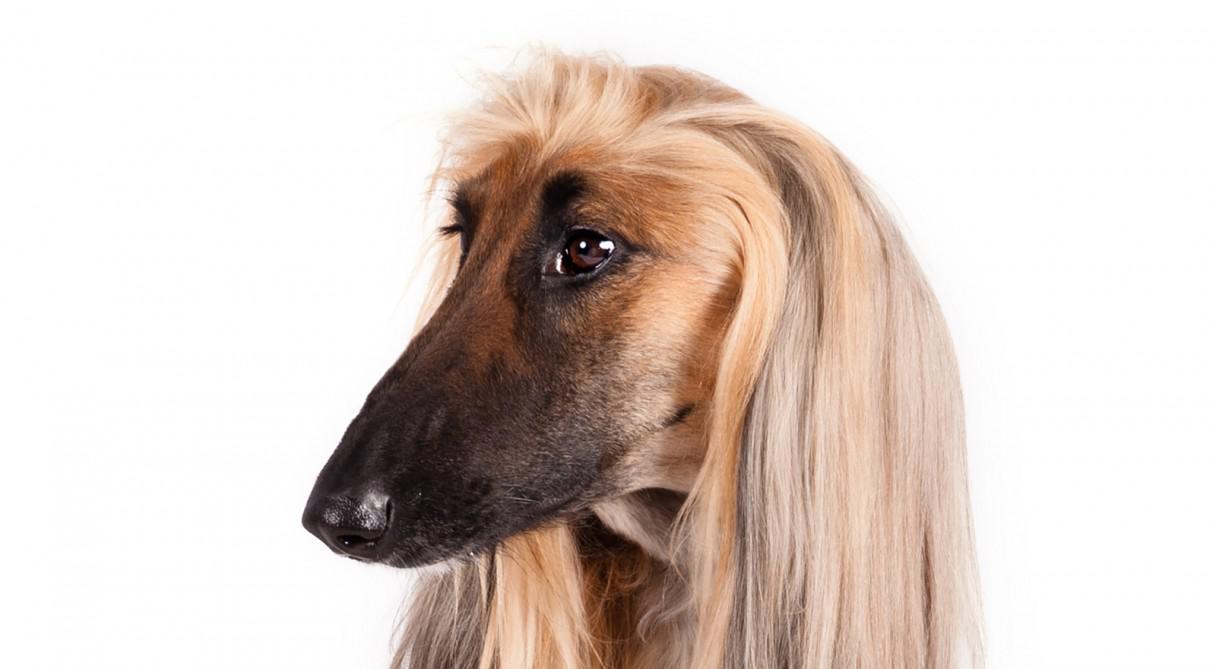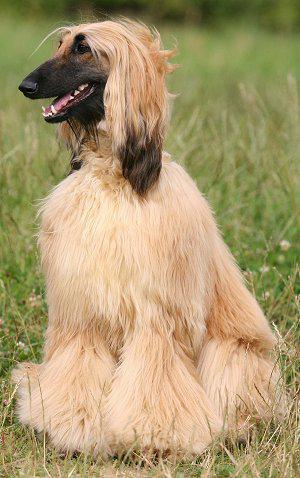The first image is the image on the left, the second image is the image on the right. Evaluate the accuracy of this statement regarding the images: "An image features an afghan hound on green grass.". Is it true? Answer yes or no. Yes. 